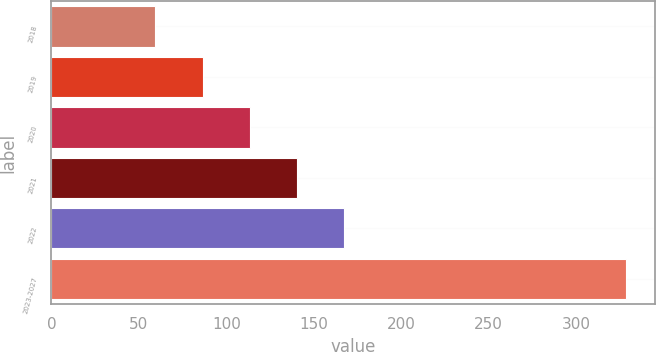Convert chart to OTSL. <chart><loc_0><loc_0><loc_500><loc_500><bar_chart><fcel>2018<fcel>2019<fcel>2020<fcel>2021<fcel>2022<fcel>2023-2027<nl><fcel>59.5<fcel>86.43<fcel>113.36<fcel>140.29<fcel>167.22<fcel>328.8<nl></chart> 